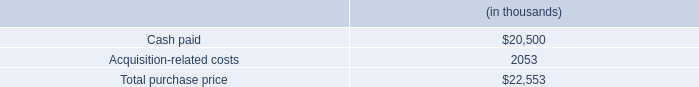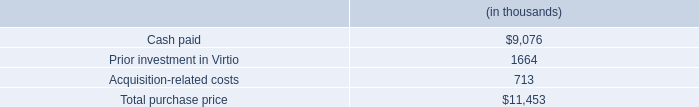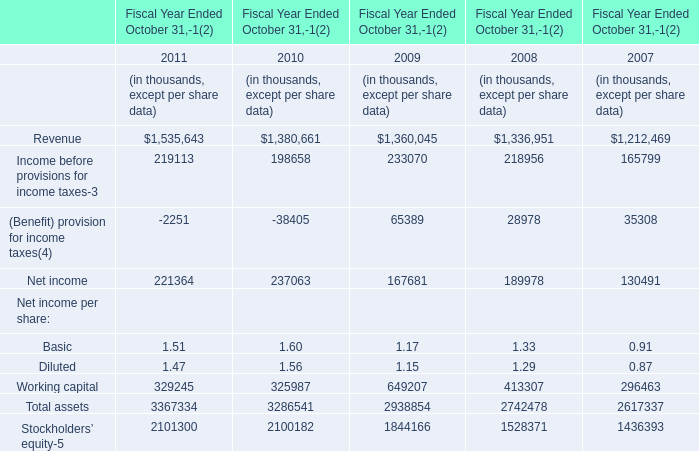What is the sum of Revenue, Income before provisions for income taxes-3 and (Benefit) provision for income taxes(4) in 2009? (in thousand) 
Computations: ((1360045 + 233070) + 65389)
Answer: 1658504.0. 